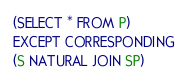<code> <loc_0><loc_0><loc_500><loc_500><_SQL_>(SELECT * FROM P)
EXCEPT CORRESPONDING
(S NATURAL JOIN SP)</code> 